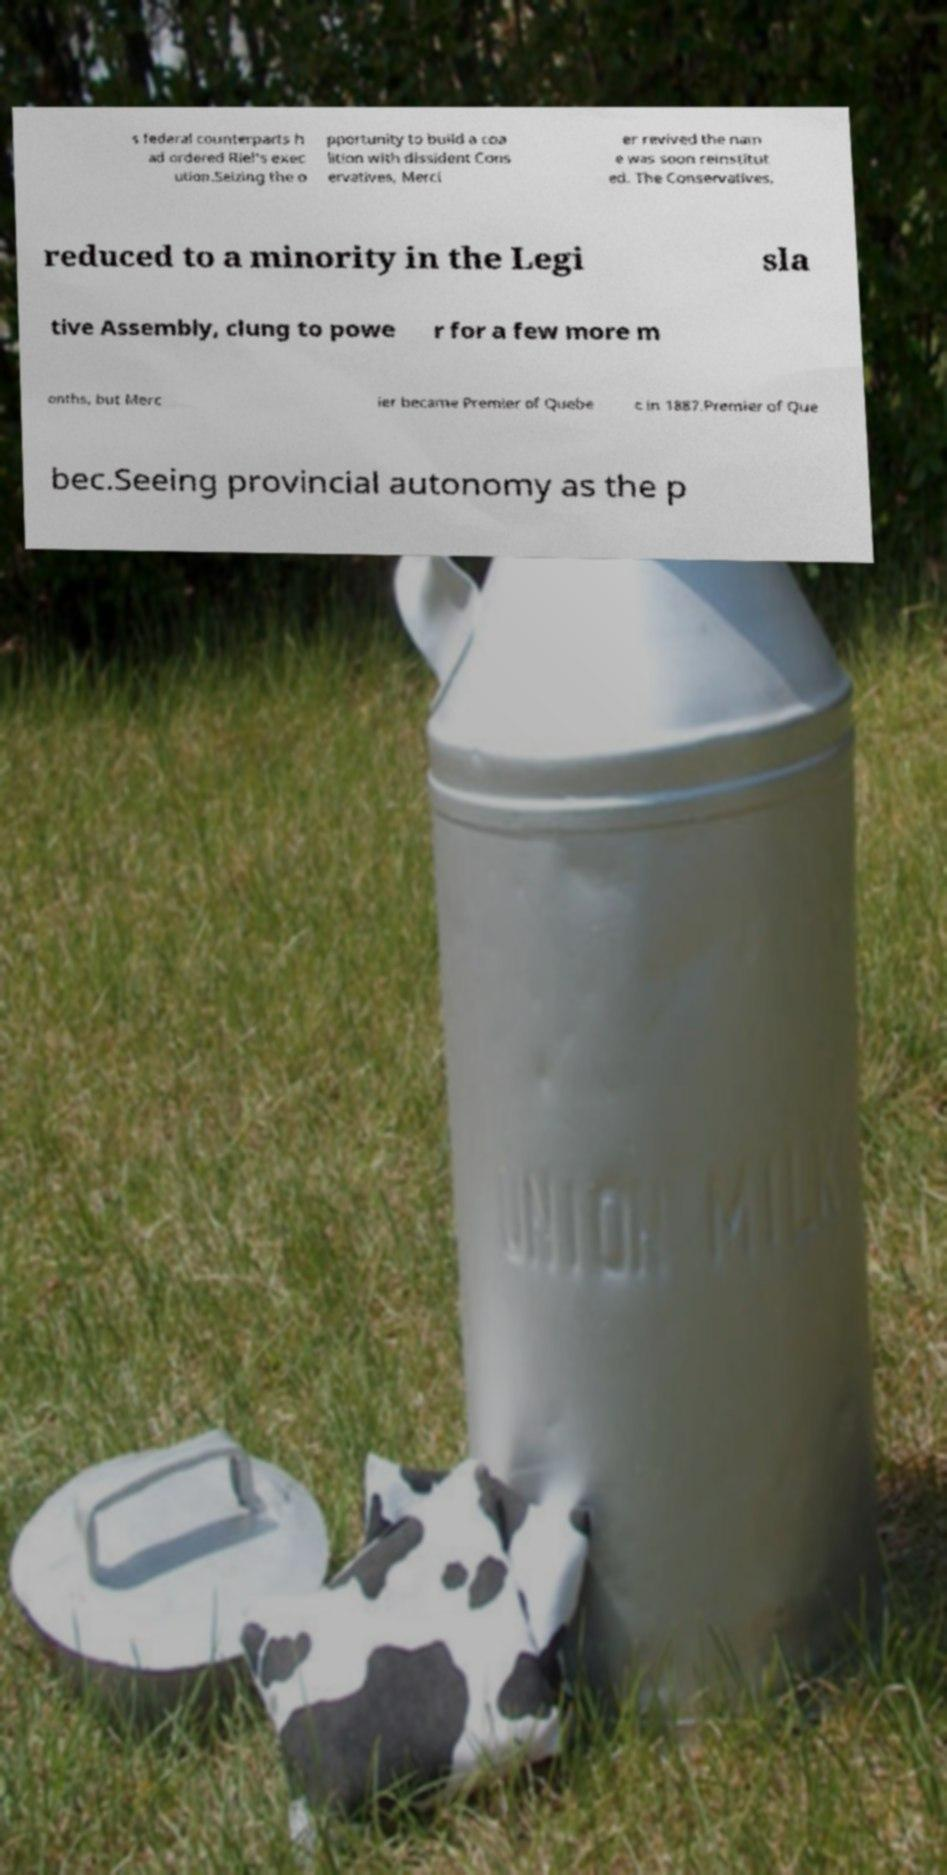Could you extract and type out the text from this image? s federal counterparts h ad ordered Riel's exec ution.Seizing the o pportunity to build a coa lition with dissident Cons ervatives, Merci er revived the nam e was soon reinstitut ed. The Conservatives, reduced to a minority in the Legi sla tive Assembly, clung to powe r for a few more m onths, but Merc ier became Premier of Quebe c in 1887.Premier of Que bec.Seeing provincial autonomy as the p 